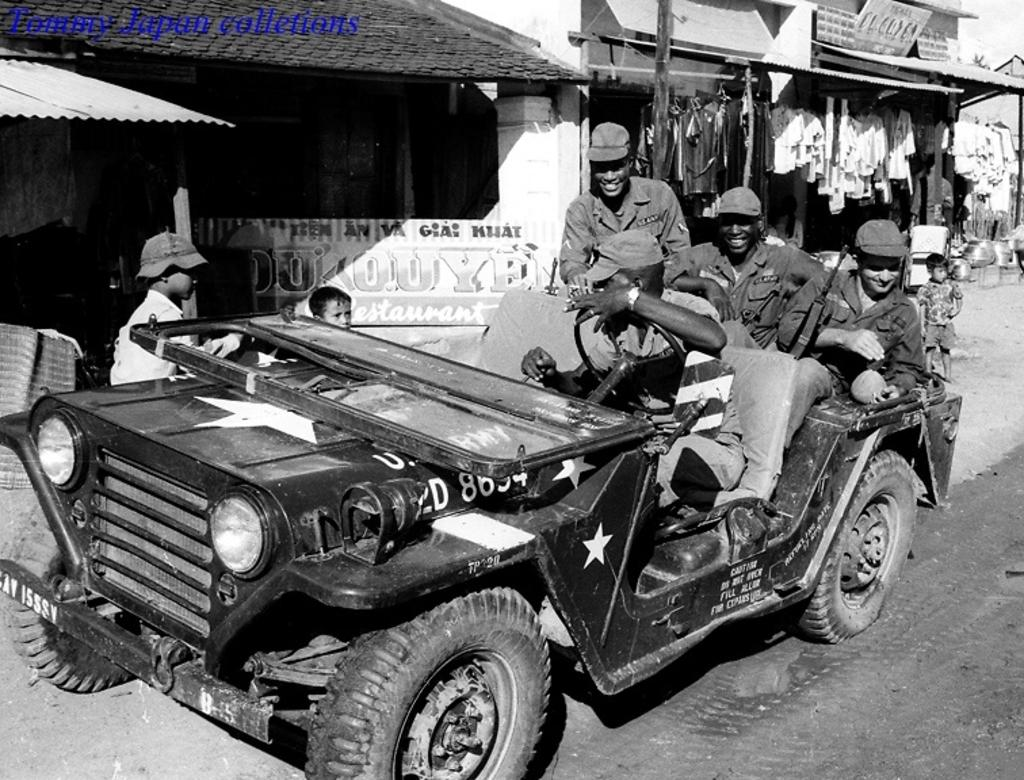What type of vehicle is in the image? There is a black color jeep in the image. Who is inside the jeep? Four military men are sitting in the jeep. What are the military men doing in the image? The military men are posing for the camera. What can be seen in the background of the image? There are small roof tile cloth shops in the background of the image. What color are the eyes of the mark in the image? There is no mark or any reference to eyes in the image; it features a black color jeep with military men posing for the camera and small roof tile cloth shops in the background. 